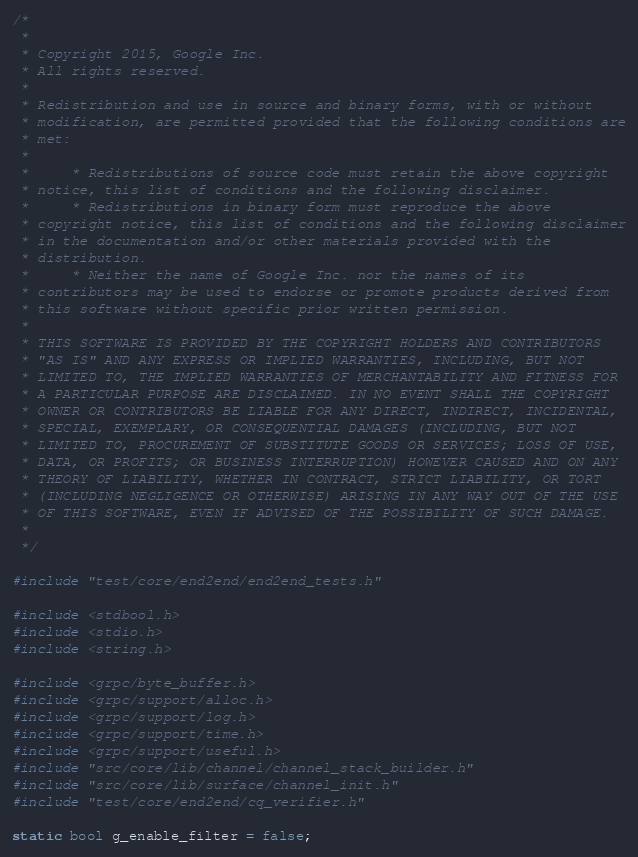<code> <loc_0><loc_0><loc_500><loc_500><_C_>/*
 *
 * Copyright 2015, Google Inc.
 * All rights reserved.
 *
 * Redistribution and use in source and binary forms, with or without
 * modification, are permitted provided that the following conditions are
 * met:
 *
 *     * Redistributions of source code must retain the above copyright
 * notice, this list of conditions and the following disclaimer.
 *     * Redistributions in binary form must reproduce the above
 * copyright notice, this list of conditions and the following disclaimer
 * in the documentation and/or other materials provided with the
 * distribution.
 *     * Neither the name of Google Inc. nor the names of its
 * contributors may be used to endorse or promote products derived from
 * this software without specific prior written permission.
 *
 * THIS SOFTWARE IS PROVIDED BY THE COPYRIGHT HOLDERS AND CONTRIBUTORS
 * "AS IS" AND ANY EXPRESS OR IMPLIED WARRANTIES, INCLUDING, BUT NOT
 * LIMITED TO, THE IMPLIED WARRANTIES OF MERCHANTABILITY AND FITNESS FOR
 * A PARTICULAR PURPOSE ARE DISCLAIMED. IN NO EVENT SHALL THE COPYRIGHT
 * OWNER OR CONTRIBUTORS BE LIABLE FOR ANY DIRECT, INDIRECT, INCIDENTAL,
 * SPECIAL, EXEMPLARY, OR CONSEQUENTIAL DAMAGES (INCLUDING, BUT NOT
 * LIMITED TO, PROCUREMENT OF SUBSTITUTE GOODS OR SERVICES; LOSS OF USE,
 * DATA, OR PROFITS; OR BUSINESS INTERRUPTION) HOWEVER CAUSED AND ON ANY
 * THEORY OF LIABILITY, WHETHER IN CONTRACT, STRICT LIABILITY, OR TORT
 * (INCLUDING NEGLIGENCE OR OTHERWISE) ARISING IN ANY WAY OUT OF THE USE
 * OF THIS SOFTWARE, EVEN IF ADVISED OF THE POSSIBILITY OF SUCH DAMAGE.
 *
 */

#include "test/core/end2end/end2end_tests.h"

#include <stdbool.h>
#include <stdio.h>
#include <string.h>

#include <grpc/byte_buffer.h>
#include <grpc/support/alloc.h>
#include <grpc/support/log.h>
#include <grpc/support/time.h>
#include <grpc/support/useful.h>
#include "src/core/lib/channel/channel_stack_builder.h"
#include "src/core/lib/surface/channel_init.h"
#include "test/core/end2end/cq_verifier.h"

static bool g_enable_filter = false;
</code> 